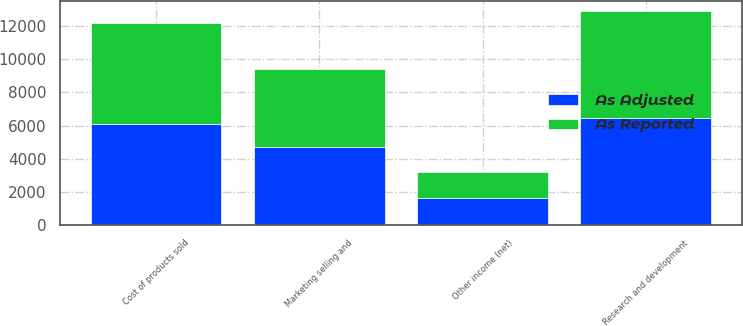Convert chart. <chart><loc_0><loc_0><loc_500><loc_500><stacked_bar_chart><ecel><fcel>Cost of products sold<fcel>Marketing selling and<fcel>Research and development<fcel>Other income (net)<nl><fcel>As Reported<fcel>6066<fcel>4687<fcel>6411<fcel>1519<nl><fcel>As Adjusted<fcel>6092<fcel>4733<fcel>6474<fcel>1654<nl></chart> 